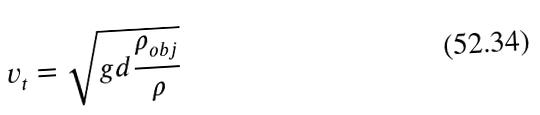Convert formula to latex. <formula><loc_0><loc_0><loc_500><loc_500>v _ { t } = \sqrt { g d \frac { \rho _ { o b j } } { \rho } }</formula> 